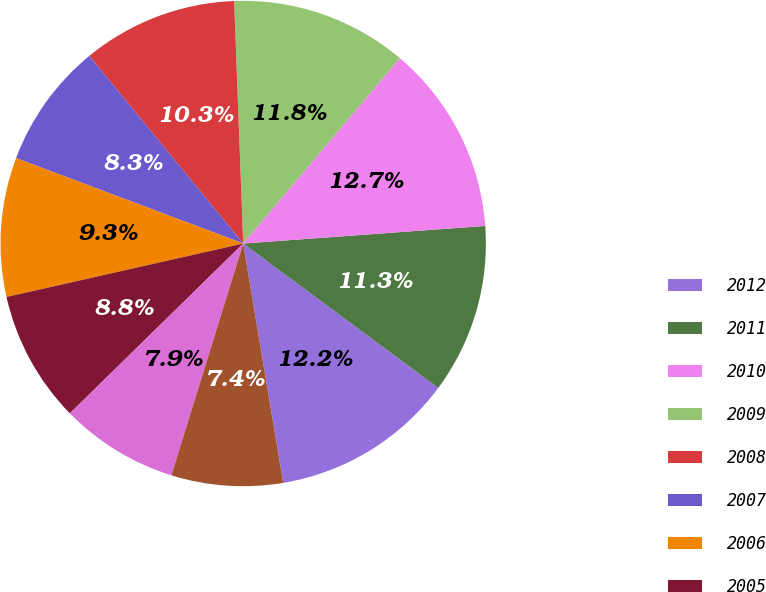<chart> <loc_0><loc_0><loc_500><loc_500><pie_chart><fcel>2012<fcel>2011<fcel>2010<fcel>2009<fcel>2008<fcel>2007<fcel>2006<fcel>2005<fcel>2004<fcel>2003<nl><fcel>12.22%<fcel>11.3%<fcel>12.68%<fcel>11.76%<fcel>10.34%<fcel>8.34%<fcel>9.26%<fcel>8.8%<fcel>7.88%<fcel>7.42%<nl></chart> 